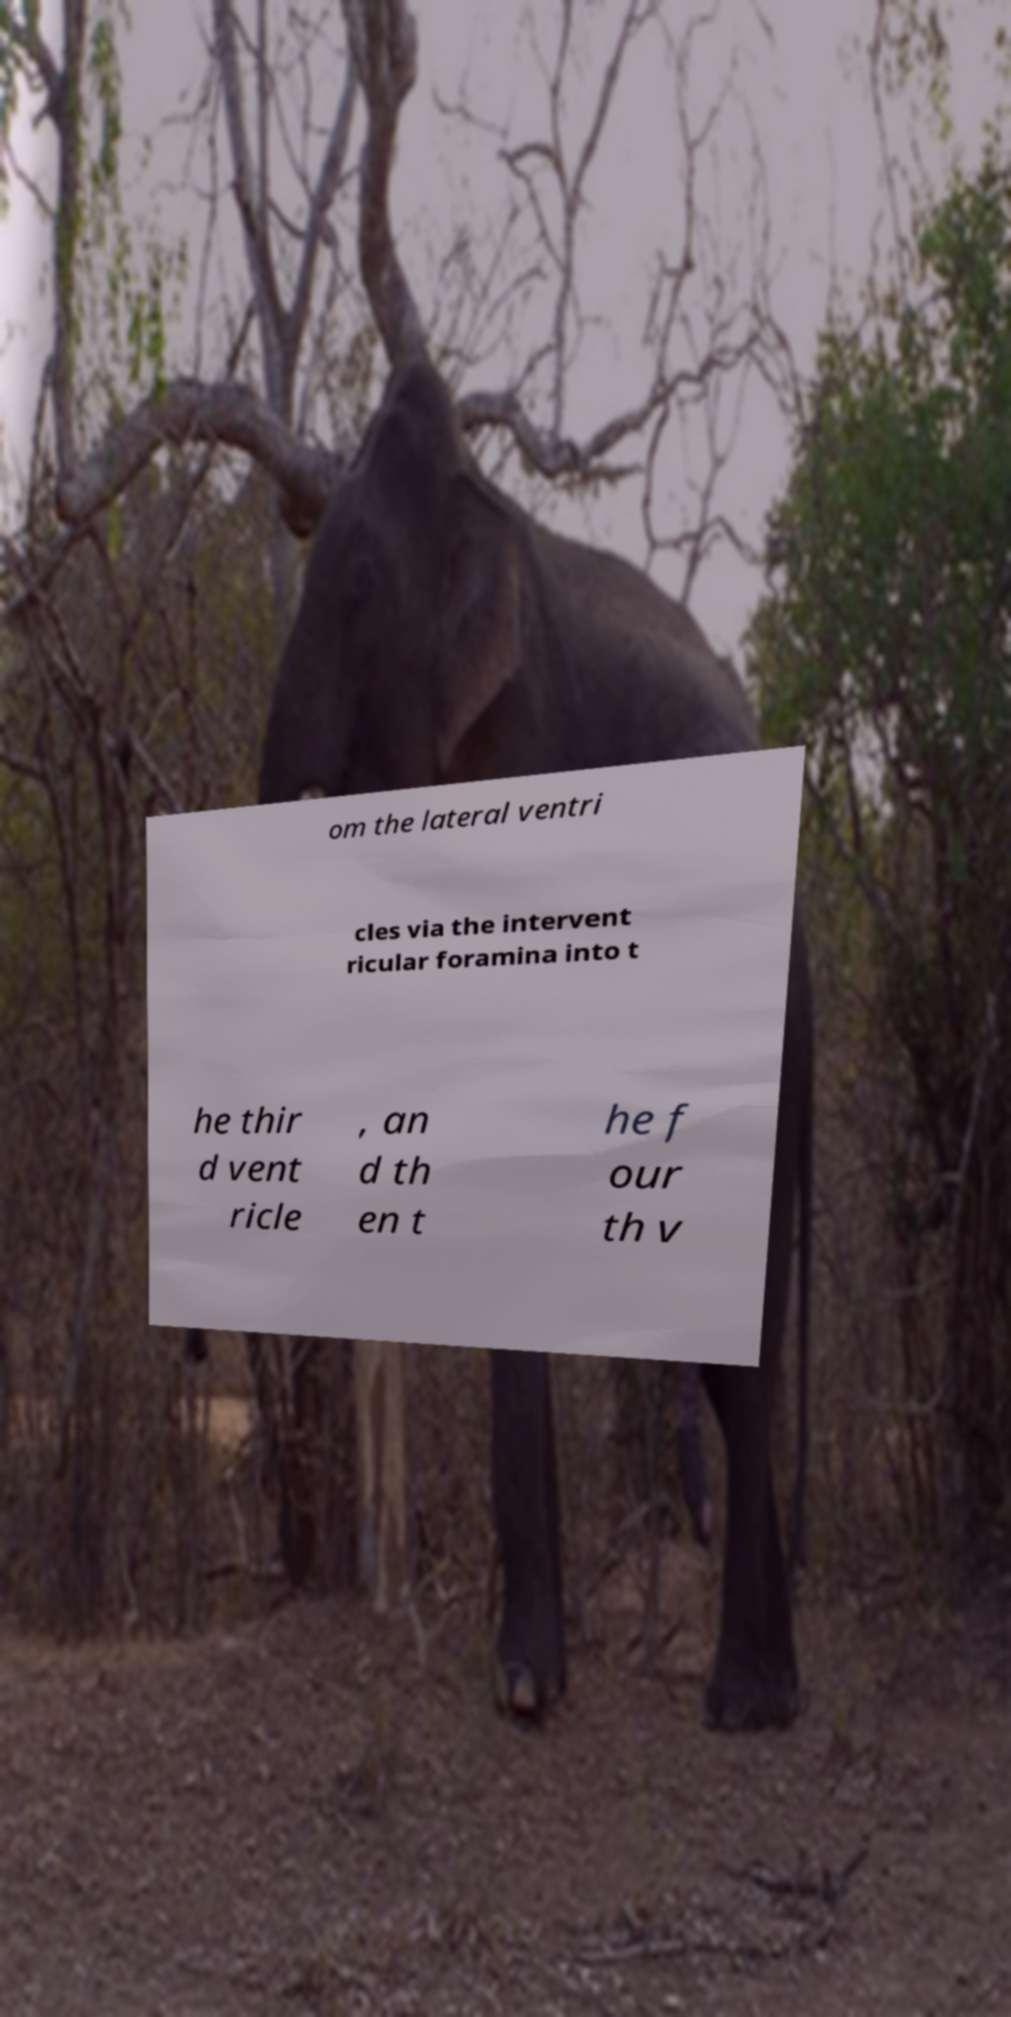Could you assist in decoding the text presented in this image and type it out clearly? om the lateral ventri cles via the intervent ricular foramina into t he thir d vent ricle , an d th en t he f our th v 